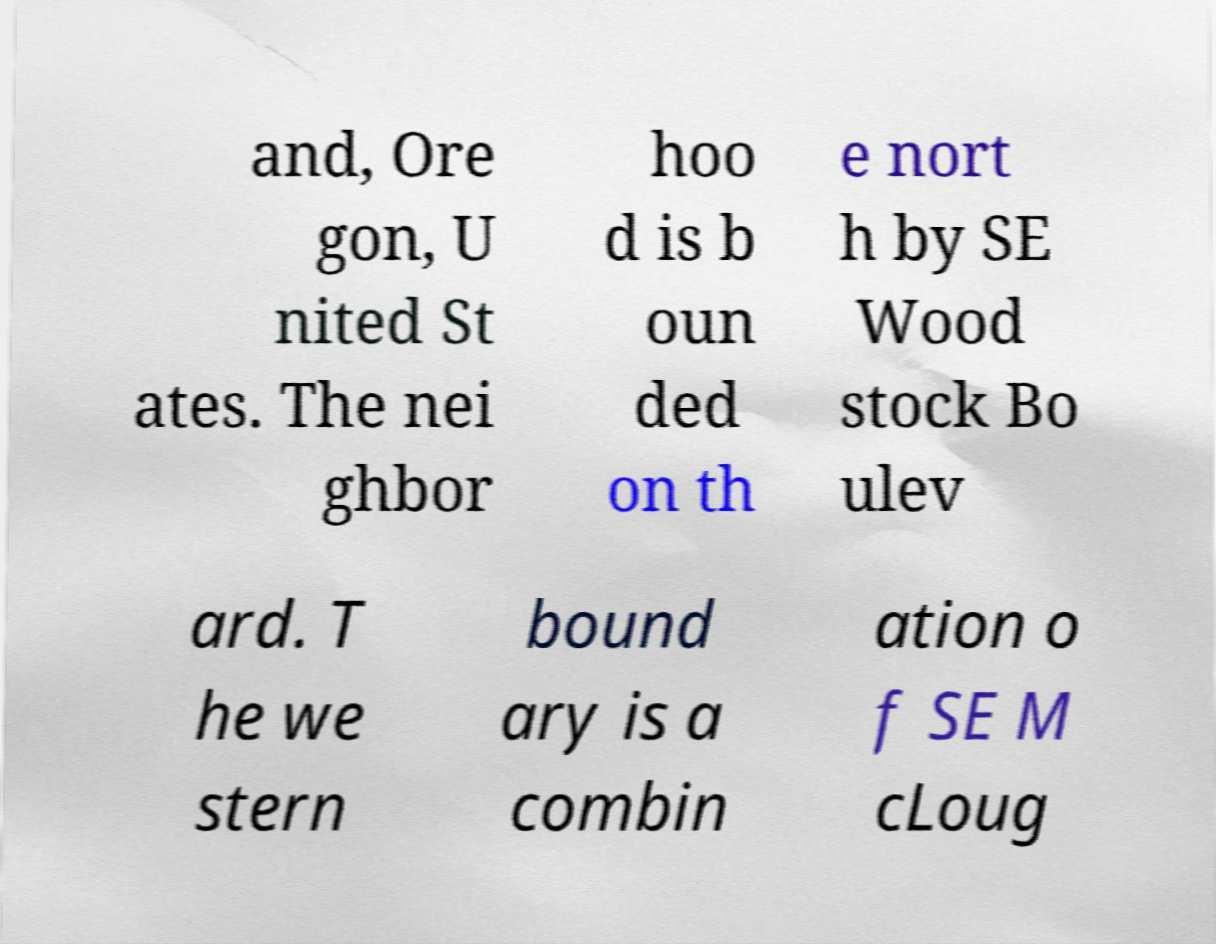Can you read and provide the text displayed in the image?This photo seems to have some interesting text. Can you extract and type it out for me? and, Ore gon, U nited St ates. The nei ghbor hoo d is b oun ded on th e nort h by SE Wood stock Bo ulev ard. T he we stern bound ary is a combin ation o f SE M cLoug 